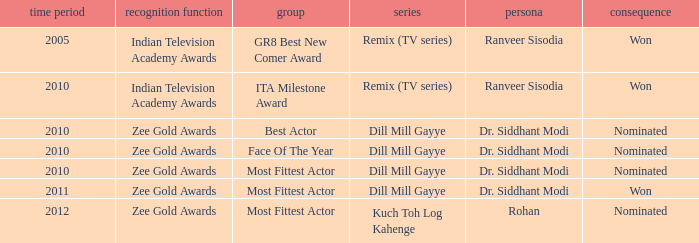Which show was nominated for the ITA Milestone Award at the Indian Television Academy Awards? Remix (TV series). Write the full table. {'header': ['time period', 'recognition function', 'group', 'series', 'persona', 'consequence'], 'rows': [['2005', 'Indian Television Academy Awards', 'GR8 Best New Comer Award', 'Remix (TV series)', 'Ranveer Sisodia', 'Won'], ['2010', 'Indian Television Academy Awards', 'ITA Milestone Award', 'Remix (TV series)', 'Ranveer Sisodia', 'Won'], ['2010', 'Zee Gold Awards', 'Best Actor', 'Dill Mill Gayye', 'Dr. Siddhant Modi', 'Nominated'], ['2010', 'Zee Gold Awards', 'Face Of The Year', 'Dill Mill Gayye', 'Dr. Siddhant Modi', 'Nominated'], ['2010', 'Zee Gold Awards', 'Most Fittest Actor', 'Dill Mill Gayye', 'Dr. Siddhant Modi', 'Nominated'], ['2011', 'Zee Gold Awards', 'Most Fittest Actor', 'Dill Mill Gayye', 'Dr. Siddhant Modi', 'Won'], ['2012', 'Zee Gold Awards', 'Most Fittest Actor', 'Kuch Toh Log Kahenge', 'Rohan', 'Nominated']]} 